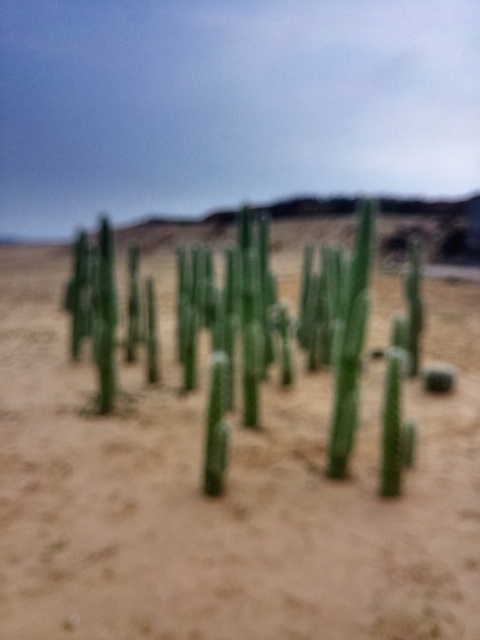What kind of cacti are these, and are they endangered? While I cannot determine the exact species from an unfocused image, these appear to be columnar cacti. Many columnar cacti species are not endangered, but some specific species could be, depending on their native range and environmental threats they face. 